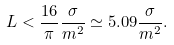<formula> <loc_0><loc_0><loc_500><loc_500>L < \frac { 1 6 } { \pi } \frac { \sigma } { m ^ { 2 } } \simeq 5 . 0 9 \frac { \sigma } { m ^ { 2 } } .</formula> 